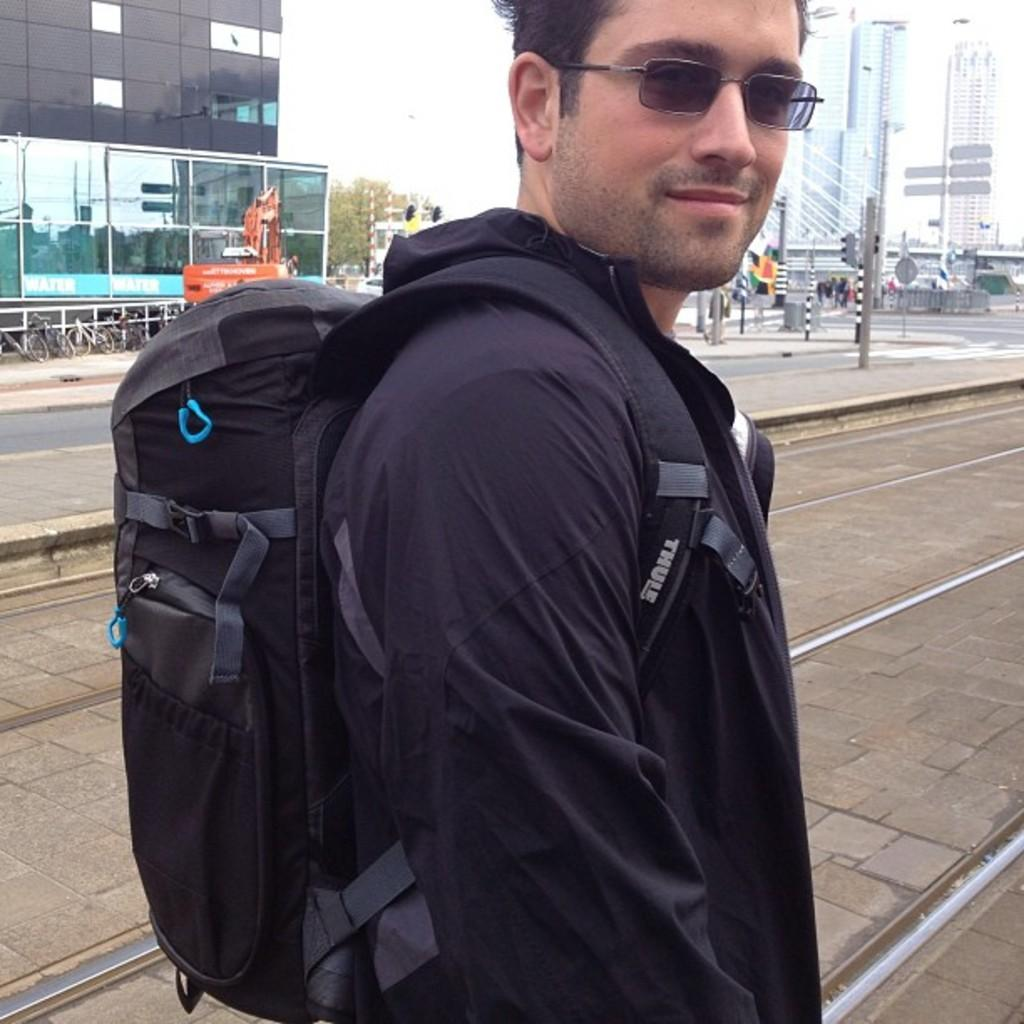Who is present in the image? There is a man in the image. What is the man wearing on his face? The man is wearing goggles. What is the man carrying on his back? The man is carrying a backpack. What type of path can be seen in the image? There is a road in the image. What type of structures are visible in the image? There are buildings visible in the image. What is the tall, thin object in the image? There is a pole in the image. What type of vegetation is present in the image? There are trees in the image. What type of sidewalk can be seen in the image? There is no sidewalk present in the image. How does the wind affect the man's goggles in the image? The image does not show any wind, and there is no indication that the goggles are affected by wind. --- Facts: 1. There is a person in the image. 2. The person is holding a book. 3. The book has a blue cover. 4. The person is sitting on a chair. 5. There is a table in the image. 6. The table has a lamp on it. Absurd Topics: ocean, rain, animal Conversation: Who is present in the image? There is a person in the image. What is the person holding? The person is holding a book. What color is the book's cover? The book has a blue cover. What is the person sitting on? The person is sitting on a chair. What type of furniture is present in the image? There is a table in the image. What is on the table? The table has a lamp on it. Reasoning: Let's think step by step in order to produce the conversation. We start by identifying the main subject in the image, which is the person. Then, we expand the conversation to include other items that are also visible, such as the book, chair, table, and lamp. Each question is designed to elicit a specific detail about the image that is known from the provided facts. Absurd Question/Answer: Can you see any ocean waves in the image? There is no ocean or waves present in the image. Is the person holding an animal in the image? There is no animal present in the image. 